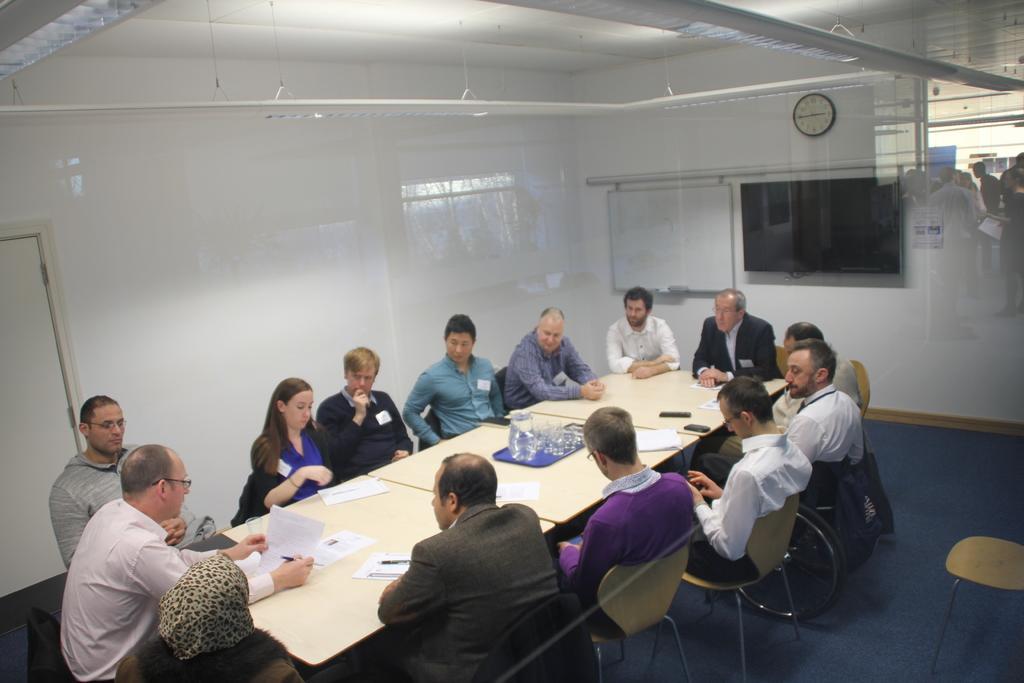How would you summarize this image in a sentence or two? This is a picture taken in a room, there are a group of people sitting on a chair in front of these people there is a table on the table there are paper, pen glasses and mobile. Behind the people there is a wall with a clock. 